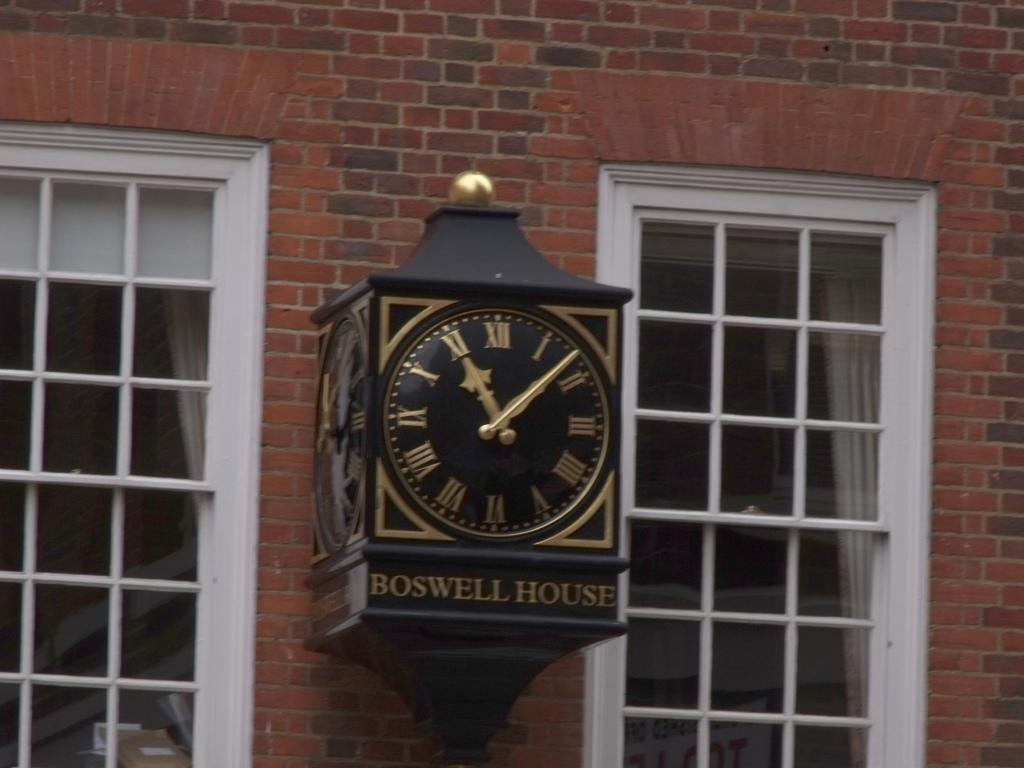Provide a one-sentence caption for the provided image. An antique looking gold and black clock with the name Boswell House on the bottom is hanging on the outside of a brick wall, between two windows. 